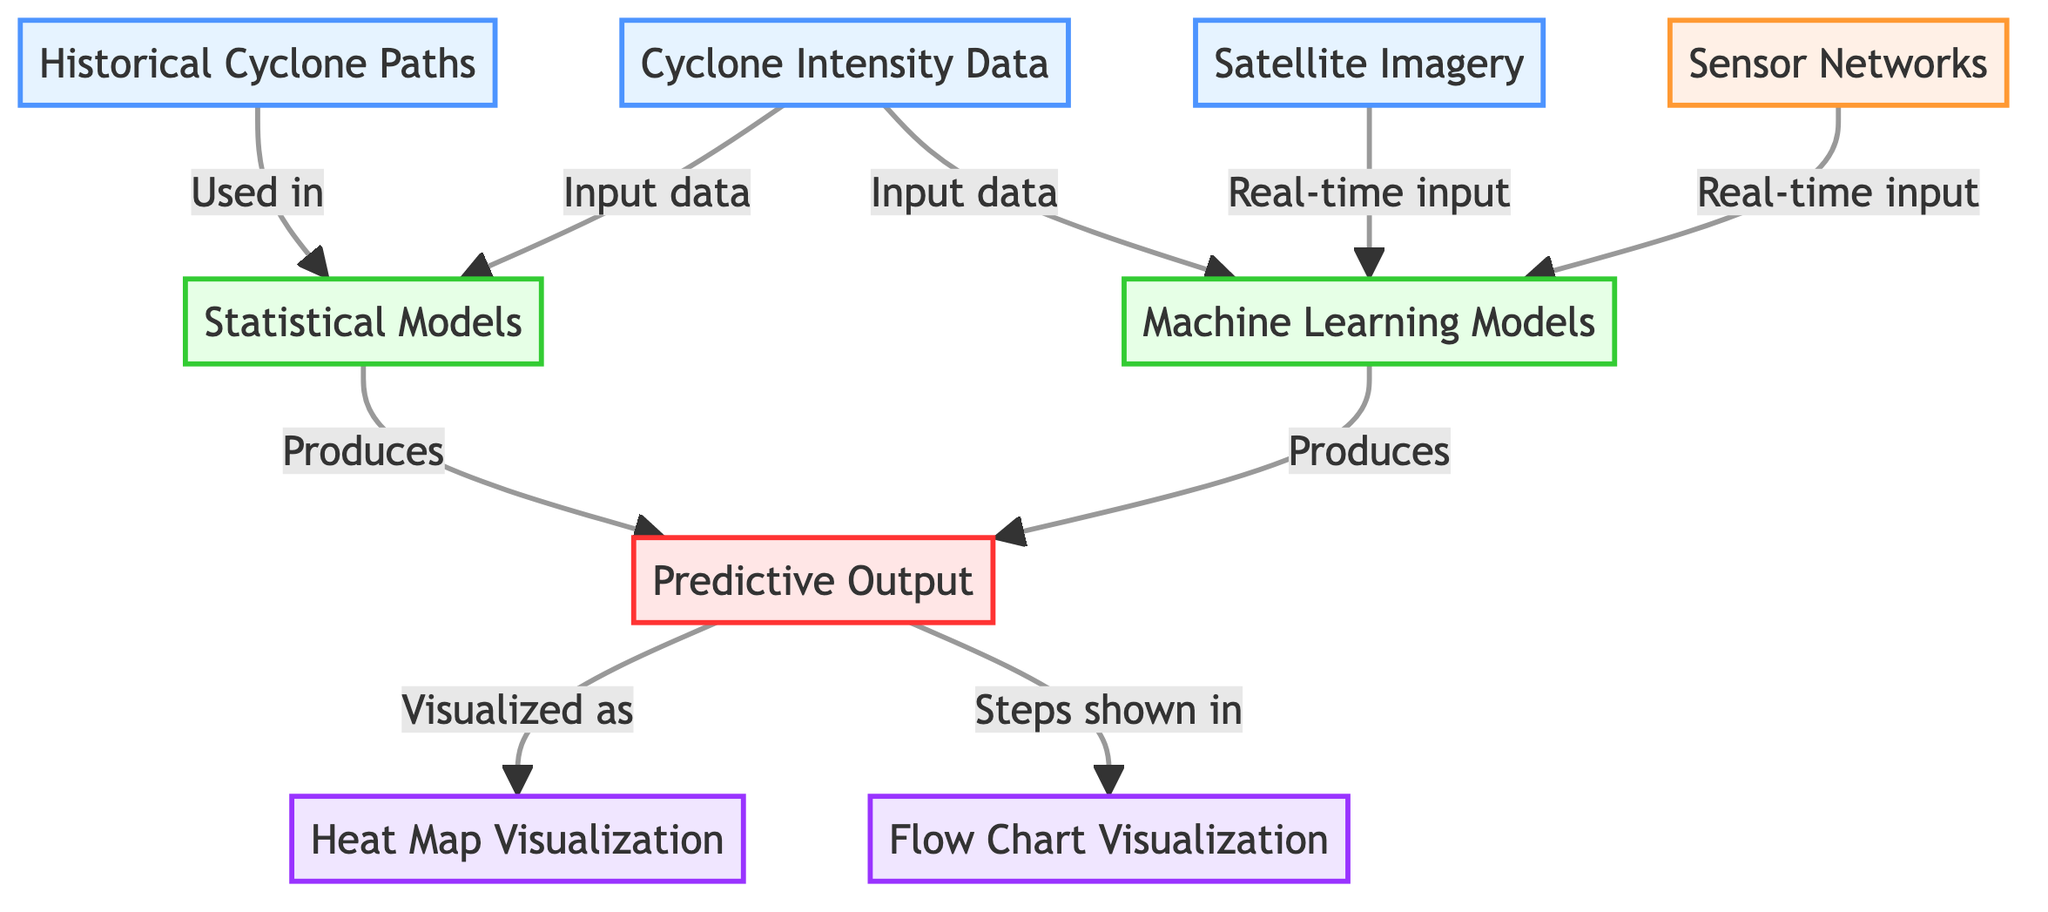What are the two types of models used in cyclone tracking? The diagram shows two model types: Statistical Models and Machine Learning Models, both leading to predictive output.
Answer: Statistical Models, Machine Learning Models How many types of visualizations are represented in the diagram? The diagram mentions two types of visualizations: Heat Map Visualization and Flow Chart Visualization.
Answer: 2 What data source provides real-time input to the Machine Learning Models? The diagram indicates that both Satellite Imagery and Sensor Networks provide real-time input to Machine Learning Models.
Answer: Satellite Imagery, Sensor Networks Which node produces the Predictive Output? The diagram shows that both Statistical Models and Machine Learning Models produce the Predictive Output.
Answer: Statistical Models, Machine Learning Models How many total data sources are utilized in the diagram? The diagram lists three data sources: Historical Cyclone Paths, Cyclone Intensity Data, and Satellite Imagery, so the total is three.
Answer: 3 What does the Predictive Output get visualized as? The diagram states that the Predictive Output is visualized as Heat Map Visualization and Flow Chart Visualization.
Answer: Heat Map Visualization, Flow Chart Visualization Which node does the Historical Cyclone Paths connect to? The Historical Cyclone Paths node connects to the Statistical Models node, indicating its use in that model.
Answer: Statistical Models What type of instrumentation is mentioned in the diagram? The single type of instrumentation mentioned is Sensor Networks, which provides real-time input.
Answer: Sensor Networks Which type of data input is shared by both Statistical and Machine Learning Models? Cyclone Intensity Data is the common input data used by both Statistical and Machine Learning Models according to the diagram.
Answer: Cyclone Intensity Data 